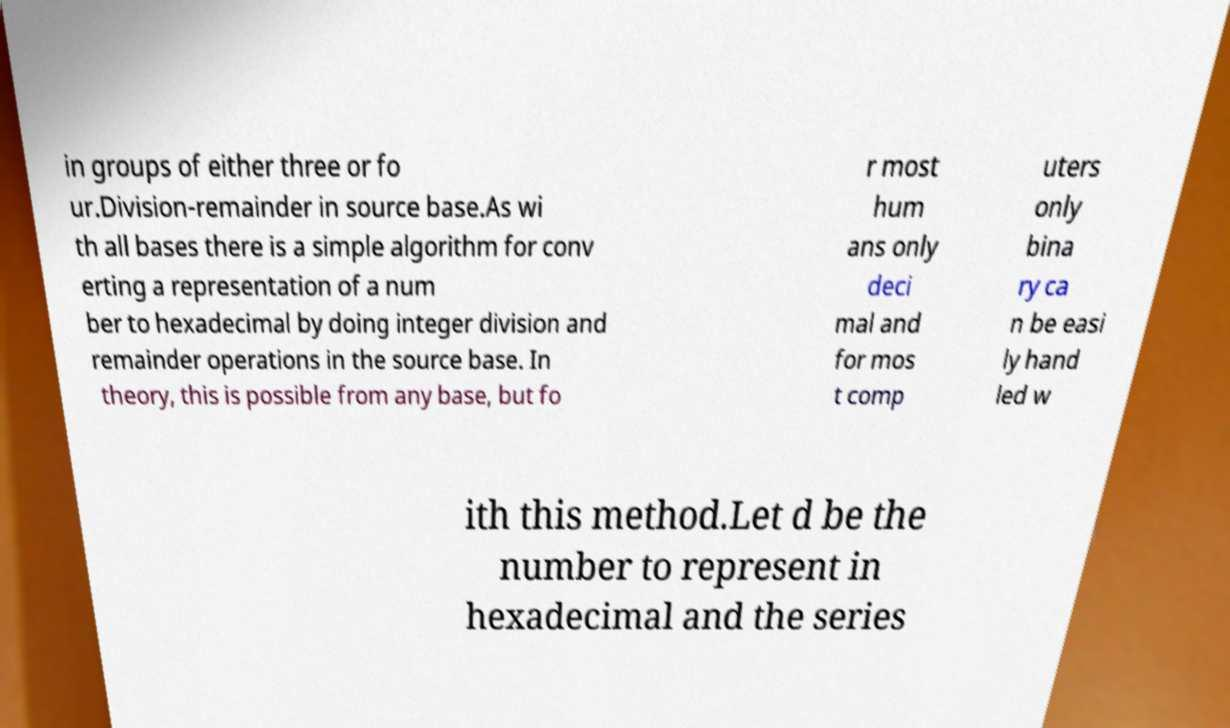Please read and relay the text visible in this image. What does it say? in groups of either three or fo ur.Division-remainder in source base.As wi th all bases there is a simple algorithm for conv erting a representation of a num ber to hexadecimal by doing integer division and remainder operations in the source base. In theory, this is possible from any base, but fo r most hum ans only deci mal and for mos t comp uters only bina ry ca n be easi ly hand led w ith this method.Let d be the number to represent in hexadecimal and the series 